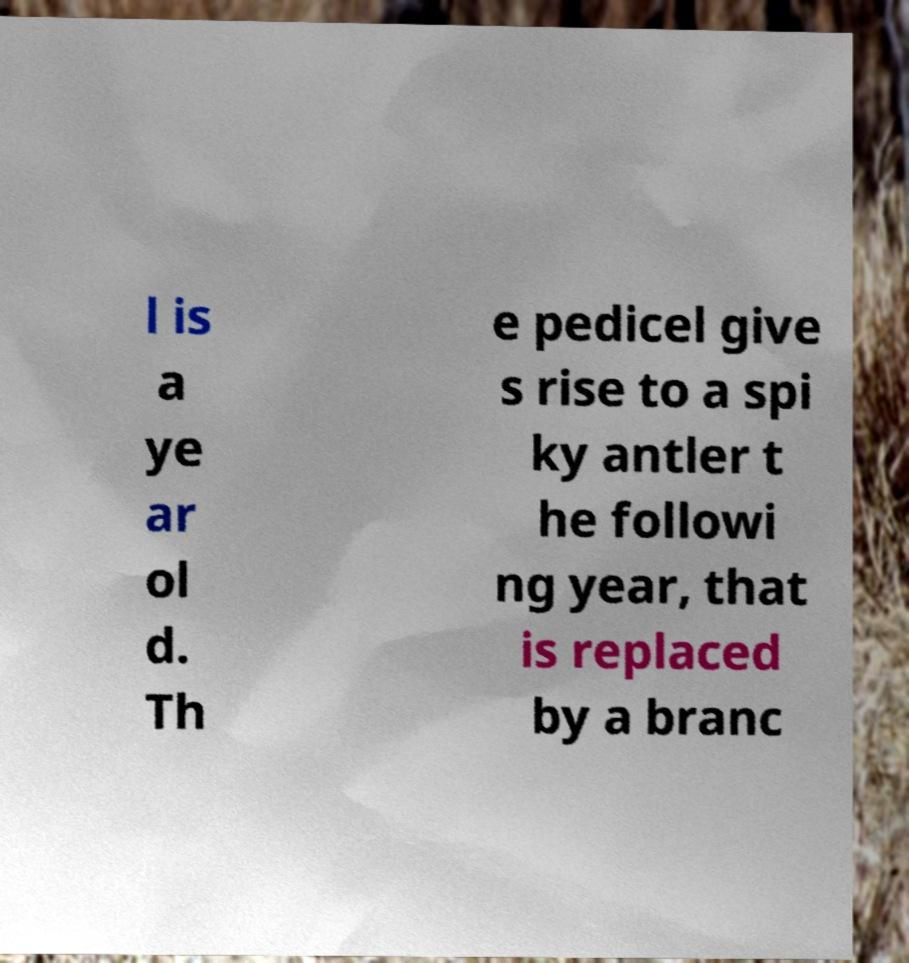Could you assist in decoding the text presented in this image and type it out clearly? l is a ye ar ol d. Th e pedicel give s rise to a spi ky antler t he followi ng year, that is replaced by a branc 